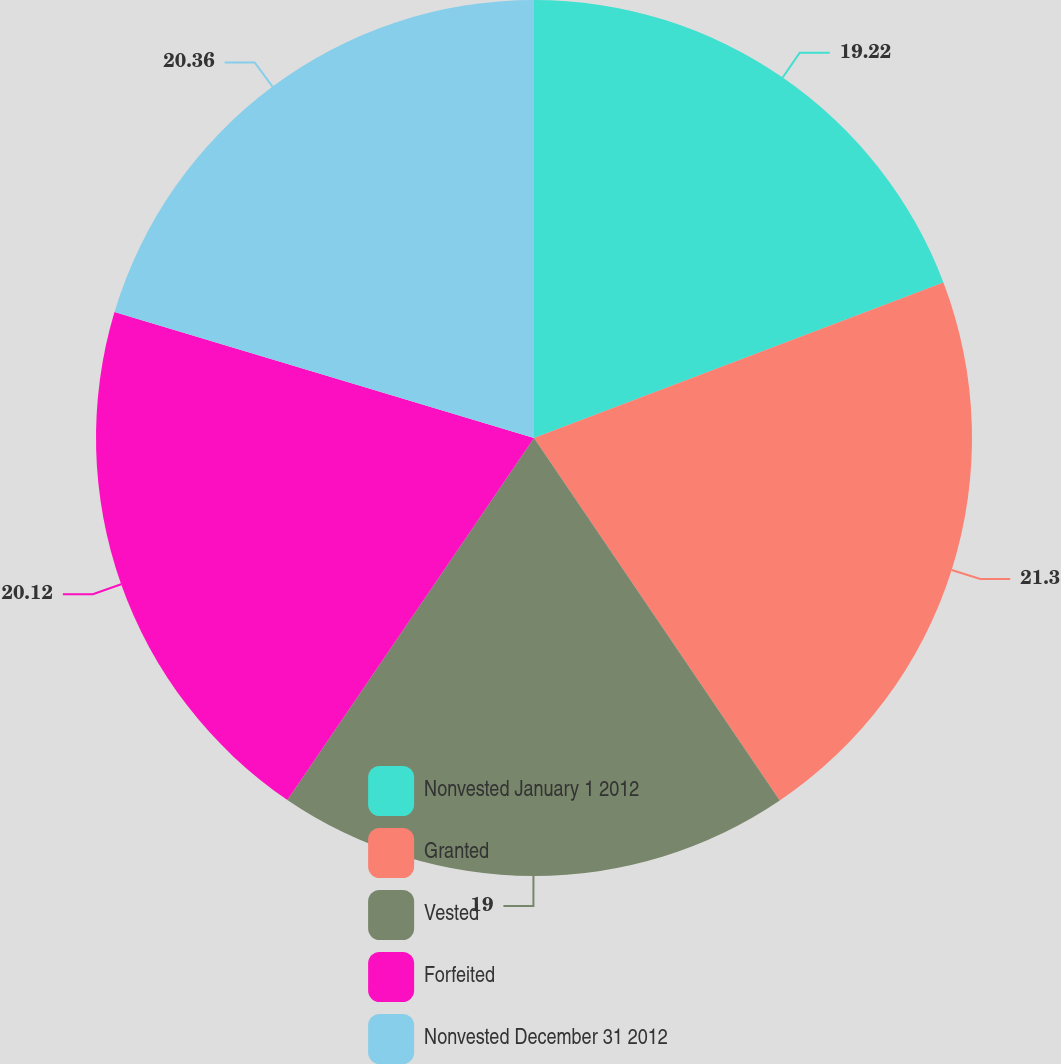Convert chart. <chart><loc_0><loc_0><loc_500><loc_500><pie_chart><fcel>Nonvested January 1 2012<fcel>Granted<fcel>Vested<fcel>Forfeited<fcel>Nonvested December 31 2012<nl><fcel>19.22%<fcel>21.3%<fcel>19.0%<fcel>20.12%<fcel>20.36%<nl></chart> 